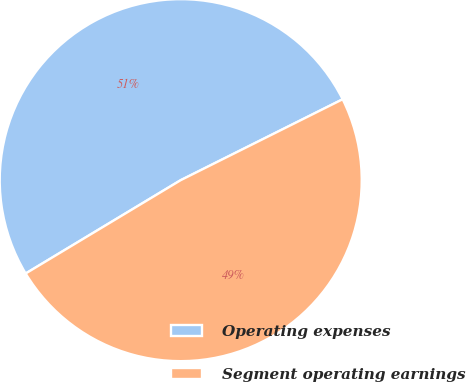Convert chart to OTSL. <chart><loc_0><loc_0><loc_500><loc_500><pie_chart><fcel>Operating expenses<fcel>Segment operating earnings<nl><fcel>51.25%<fcel>48.75%<nl></chart> 